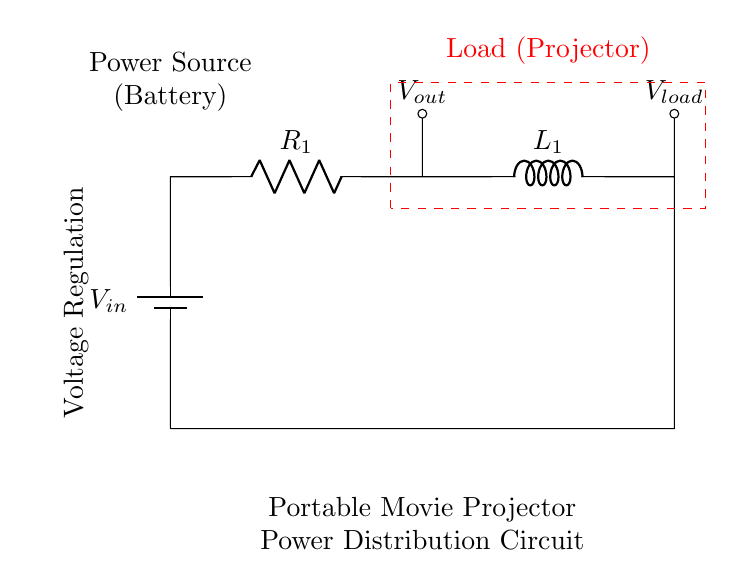What is the input voltage of this circuit? The input voltage is labeled as V_in at the top of the circuit diagram, indicating the voltage supplied by the battery.
Answer: V_in What is the component labeled R_1? R_1 represents a resistor in the circuit, which is used for controlling the current flowing through the circuit.
Answer: Resistor What is the purpose of the component L_1 in this circuit? L_1 is an inductor, which serves to store energy in the magnetic field when current passes through it. It also helps in smoothing out fluctuations in current.
Answer: Energy storage What voltage is provided to the load? The voltage provided to the load is indicated as V_load, which shows the output voltage across the load component connected to L_1.
Answer: V_load What type of circuit is shown in the diagram? The circuit shown is specifically a Resistor-Inductor circuit, as it contains both a resistor and an inductor arranged to work together in managing power distribution.
Answer: Resistor-Inductor What is the function of the dashed rectangle in the diagram? The dashed rectangle highlights the load section of the circuit, where the portable movie projector is connected, capturing the area that draws power from the circuit.
Answer: Load Why is voltage regulation mentioned in the diagram? Voltage regulation is essential in this circuit to ensure that the load (projector) receives a stable voltage, regardless of variations in the input voltage or load conditions.
Answer: Stability 